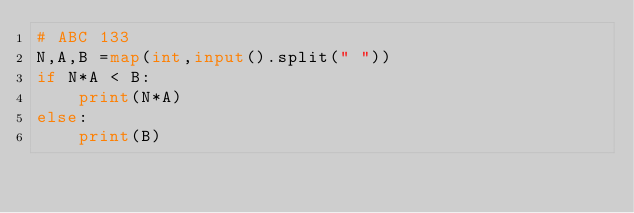<code> <loc_0><loc_0><loc_500><loc_500><_Python_># ABC 133
N,A,B =map(int,input().split(" "))
if N*A < B:
    print(N*A)
else:
    print(B)

   </code> 